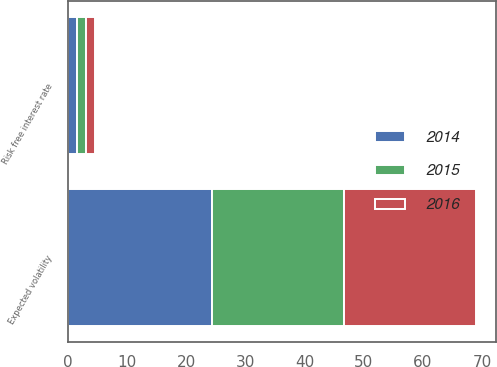<chart> <loc_0><loc_0><loc_500><loc_500><stacked_bar_chart><ecel><fcel>Risk free interest rate<fcel>Expected volatility<nl><fcel>2016<fcel>1.44<fcel>22.3<nl><fcel>2015<fcel>1.52<fcel>22.3<nl><fcel>2014<fcel>1.6<fcel>24.3<nl></chart> 